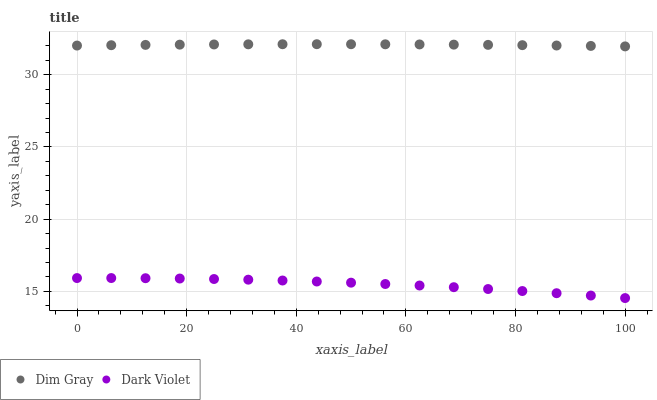Does Dark Violet have the minimum area under the curve?
Answer yes or no. Yes. Does Dim Gray have the maximum area under the curve?
Answer yes or no. Yes. Does Dark Violet have the maximum area under the curve?
Answer yes or no. No. Is Dim Gray the smoothest?
Answer yes or no. Yes. Is Dark Violet the roughest?
Answer yes or no. Yes. Is Dark Violet the smoothest?
Answer yes or no. No. Does Dark Violet have the lowest value?
Answer yes or no. Yes. Does Dim Gray have the highest value?
Answer yes or no. Yes. Does Dark Violet have the highest value?
Answer yes or no. No. Is Dark Violet less than Dim Gray?
Answer yes or no. Yes. Is Dim Gray greater than Dark Violet?
Answer yes or no. Yes. Does Dark Violet intersect Dim Gray?
Answer yes or no. No. 